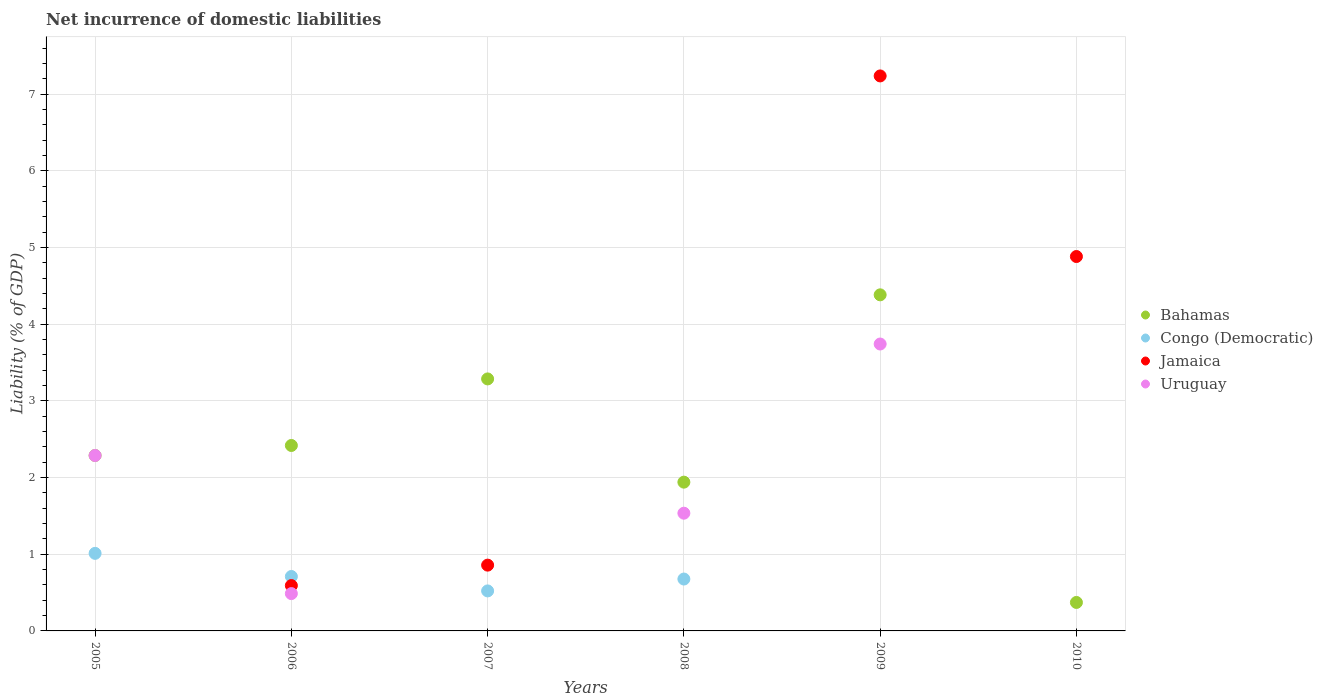How many different coloured dotlines are there?
Ensure brevity in your answer.  4. What is the net incurrence of domestic liabilities in Bahamas in 2005?
Offer a terse response. 2.29. Across all years, what is the maximum net incurrence of domestic liabilities in Congo (Democratic)?
Your answer should be very brief. 1.01. Across all years, what is the minimum net incurrence of domestic liabilities in Uruguay?
Your response must be concise. 0. What is the total net incurrence of domestic liabilities in Bahamas in the graph?
Give a very brief answer. 14.69. What is the difference between the net incurrence of domestic liabilities in Bahamas in 2008 and that in 2010?
Your answer should be compact. 1.57. What is the difference between the net incurrence of domestic liabilities in Bahamas in 2006 and the net incurrence of domestic liabilities in Jamaica in 2008?
Give a very brief answer. 2.42. What is the average net incurrence of domestic liabilities in Jamaica per year?
Offer a very short reply. 2.26. In the year 2006, what is the difference between the net incurrence of domestic liabilities in Uruguay and net incurrence of domestic liabilities in Congo (Democratic)?
Provide a succinct answer. -0.22. In how many years, is the net incurrence of domestic liabilities in Jamaica greater than 0.8 %?
Your response must be concise. 3. What is the ratio of the net incurrence of domestic liabilities in Congo (Democratic) in 2005 to that in 2007?
Ensure brevity in your answer.  1.94. Is the net incurrence of domestic liabilities in Bahamas in 2007 less than that in 2009?
Make the answer very short. Yes. What is the difference between the highest and the second highest net incurrence of domestic liabilities in Congo (Democratic)?
Provide a short and direct response. 0.3. What is the difference between the highest and the lowest net incurrence of domestic liabilities in Congo (Democratic)?
Provide a succinct answer. 1.01. Is it the case that in every year, the sum of the net incurrence of domestic liabilities in Jamaica and net incurrence of domestic liabilities in Congo (Democratic)  is greater than the sum of net incurrence of domestic liabilities in Bahamas and net incurrence of domestic liabilities in Uruguay?
Offer a very short reply. No. Is the net incurrence of domestic liabilities in Jamaica strictly greater than the net incurrence of domestic liabilities in Bahamas over the years?
Your response must be concise. No. Is the net incurrence of domestic liabilities in Jamaica strictly less than the net incurrence of domestic liabilities in Congo (Democratic) over the years?
Your response must be concise. No. How many dotlines are there?
Provide a succinct answer. 4. What is the difference between two consecutive major ticks on the Y-axis?
Make the answer very short. 1. Where does the legend appear in the graph?
Offer a terse response. Center right. How many legend labels are there?
Your answer should be very brief. 4. How are the legend labels stacked?
Offer a terse response. Vertical. What is the title of the graph?
Your response must be concise. Net incurrence of domestic liabilities. Does "Equatorial Guinea" appear as one of the legend labels in the graph?
Your response must be concise. No. What is the label or title of the X-axis?
Offer a terse response. Years. What is the label or title of the Y-axis?
Ensure brevity in your answer.  Liability (% of GDP). What is the Liability (% of GDP) of Bahamas in 2005?
Your answer should be compact. 2.29. What is the Liability (% of GDP) in Congo (Democratic) in 2005?
Give a very brief answer. 1.01. What is the Liability (% of GDP) of Jamaica in 2005?
Your response must be concise. 0. What is the Liability (% of GDP) in Uruguay in 2005?
Your response must be concise. 2.29. What is the Liability (% of GDP) of Bahamas in 2006?
Your response must be concise. 2.42. What is the Liability (% of GDP) of Congo (Democratic) in 2006?
Provide a short and direct response. 0.71. What is the Liability (% of GDP) of Jamaica in 2006?
Your response must be concise. 0.59. What is the Liability (% of GDP) in Uruguay in 2006?
Provide a succinct answer. 0.49. What is the Liability (% of GDP) in Bahamas in 2007?
Provide a succinct answer. 3.29. What is the Liability (% of GDP) of Congo (Democratic) in 2007?
Keep it short and to the point. 0.52. What is the Liability (% of GDP) in Jamaica in 2007?
Provide a short and direct response. 0.86. What is the Liability (% of GDP) of Uruguay in 2007?
Keep it short and to the point. 0. What is the Liability (% of GDP) in Bahamas in 2008?
Your answer should be very brief. 1.94. What is the Liability (% of GDP) in Congo (Democratic) in 2008?
Keep it short and to the point. 0.68. What is the Liability (% of GDP) of Jamaica in 2008?
Make the answer very short. 0. What is the Liability (% of GDP) in Uruguay in 2008?
Make the answer very short. 1.54. What is the Liability (% of GDP) of Bahamas in 2009?
Ensure brevity in your answer.  4.38. What is the Liability (% of GDP) in Jamaica in 2009?
Your answer should be very brief. 7.24. What is the Liability (% of GDP) in Uruguay in 2009?
Make the answer very short. 3.74. What is the Liability (% of GDP) in Bahamas in 2010?
Offer a very short reply. 0.37. What is the Liability (% of GDP) in Jamaica in 2010?
Make the answer very short. 4.88. What is the Liability (% of GDP) of Uruguay in 2010?
Offer a very short reply. 0. Across all years, what is the maximum Liability (% of GDP) of Bahamas?
Your answer should be very brief. 4.38. Across all years, what is the maximum Liability (% of GDP) of Congo (Democratic)?
Ensure brevity in your answer.  1.01. Across all years, what is the maximum Liability (% of GDP) of Jamaica?
Keep it short and to the point. 7.24. Across all years, what is the maximum Liability (% of GDP) of Uruguay?
Provide a succinct answer. 3.74. Across all years, what is the minimum Liability (% of GDP) of Bahamas?
Make the answer very short. 0.37. Across all years, what is the minimum Liability (% of GDP) in Congo (Democratic)?
Keep it short and to the point. 0. Across all years, what is the minimum Liability (% of GDP) in Jamaica?
Offer a very short reply. 0. What is the total Liability (% of GDP) of Bahamas in the graph?
Ensure brevity in your answer.  14.69. What is the total Liability (% of GDP) of Congo (Democratic) in the graph?
Ensure brevity in your answer.  2.92. What is the total Liability (% of GDP) of Jamaica in the graph?
Offer a terse response. 13.57. What is the total Liability (% of GDP) in Uruguay in the graph?
Your response must be concise. 8.05. What is the difference between the Liability (% of GDP) in Bahamas in 2005 and that in 2006?
Provide a succinct answer. -0.13. What is the difference between the Liability (% of GDP) of Congo (Democratic) in 2005 and that in 2006?
Your response must be concise. 0.3. What is the difference between the Liability (% of GDP) in Uruguay in 2005 and that in 2006?
Make the answer very short. 1.8. What is the difference between the Liability (% of GDP) in Bahamas in 2005 and that in 2007?
Your answer should be compact. -1. What is the difference between the Liability (% of GDP) of Congo (Democratic) in 2005 and that in 2007?
Your answer should be very brief. 0.49. What is the difference between the Liability (% of GDP) of Bahamas in 2005 and that in 2008?
Your answer should be very brief. 0.35. What is the difference between the Liability (% of GDP) in Congo (Democratic) in 2005 and that in 2008?
Give a very brief answer. 0.33. What is the difference between the Liability (% of GDP) in Uruguay in 2005 and that in 2008?
Your answer should be very brief. 0.75. What is the difference between the Liability (% of GDP) of Bahamas in 2005 and that in 2009?
Your answer should be compact. -2.1. What is the difference between the Liability (% of GDP) of Uruguay in 2005 and that in 2009?
Offer a very short reply. -1.45. What is the difference between the Liability (% of GDP) in Bahamas in 2005 and that in 2010?
Keep it short and to the point. 1.92. What is the difference between the Liability (% of GDP) in Bahamas in 2006 and that in 2007?
Offer a very short reply. -0.87. What is the difference between the Liability (% of GDP) of Congo (Democratic) in 2006 and that in 2007?
Offer a very short reply. 0.19. What is the difference between the Liability (% of GDP) in Jamaica in 2006 and that in 2007?
Your answer should be compact. -0.27. What is the difference between the Liability (% of GDP) of Bahamas in 2006 and that in 2008?
Provide a succinct answer. 0.48. What is the difference between the Liability (% of GDP) in Congo (Democratic) in 2006 and that in 2008?
Offer a very short reply. 0.03. What is the difference between the Liability (% of GDP) in Uruguay in 2006 and that in 2008?
Offer a terse response. -1.05. What is the difference between the Liability (% of GDP) in Bahamas in 2006 and that in 2009?
Offer a terse response. -1.96. What is the difference between the Liability (% of GDP) of Jamaica in 2006 and that in 2009?
Keep it short and to the point. -6.65. What is the difference between the Liability (% of GDP) of Uruguay in 2006 and that in 2009?
Offer a terse response. -3.25. What is the difference between the Liability (% of GDP) in Bahamas in 2006 and that in 2010?
Your response must be concise. 2.05. What is the difference between the Liability (% of GDP) in Jamaica in 2006 and that in 2010?
Provide a short and direct response. -4.29. What is the difference between the Liability (% of GDP) in Bahamas in 2007 and that in 2008?
Your answer should be compact. 1.35. What is the difference between the Liability (% of GDP) in Congo (Democratic) in 2007 and that in 2008?
Offer a terse response. -0.15. What is the difference between the Liability (% of GDP) in Bahamas in 2007 and that in 2009?
Ensure brevity in your answer.  -1.1. What is the difference between the Liability (% of GDP) of Jamaica in 2007 and that in 2009?
Provide a succinct answer. -6.38. What is the difference between the Liability (% of GDP) in Bahamas in 2007 and that in 2010?
Make the answer very short. 2.92. What is the difference between the Liability (% of GDP) in Jamaica in 2007 and that in 2010?
Provide a short and direct response. -4.02. What is the difference between the Liability (% of GDP) in Bahamas in 2008 and that in 2009?
Make the answer very short. -2.44. What is the difference between the Liability (% of GDP) in Uruguay in 2008 and that in 2009?
Ensure brevity in your answer.  -2.21. What is the difference between the Liability (% of GDP) of Bahamas in 2008 and that in 2010?
Ensure brevity in your answer.  1.57. What is the difference between the Liability (% of GDP) in Bahamas in 2009 and that in 2010?
Offer a terse response. 4.01. What is the difference between the Liability (% of GDP) of Jamaica in 2009 and that in 2010?
Offer a terse response. 2.36. What is the difference between the Liability (% of GDP) of Bahamas in 2005 and the Liability (% of GDP) of Congo (Democratic) in 2006?
Provide a short and direct response. 1.58. What is the difference between the Liability (% of GDP) in Bahamas in 2005 and the Liability (% of GDP) in Jamaica in 2006?
Your response must be concise. 1.7. What is the difference between the Liability (% of GDP) of Bahamas in 2005 and the Liability (% of GDP) of Uruguay in 2006?
Your response must be concise. 1.8. What is the difference between the Liability (% of GDP) in Congo (Democratic) in 2005 and the Liability (% of GDP) in Jamaica in 2006?
Your answer should be compact. 0.42. What is the difference between the Liability (% of GDP) in Congo (Democratic) in 2005 and the Liability (% of GDP) in Uruguay in 2006?
Ensure brevity in your answer.  0.52. What is the difference between the Liability (% of GDP) of Bahamas in 2005 and the Liability (% of GDP) of Congo (Democratic) in 2007?
Your answer should be very brief. 1.77. What is the difference between the Liability (% of GDP) of Bahamas in 2005 and the Liability (% of GDP) of Jamaica in 2007?
Your response must be concise. 1.43. What is the difference between the Liability (% of GDP) in Congo (Democratic) in 2005 and the Liability (% of GDP) in Jamaica in 2007?
Ensure brevity in your answer.  0.15. What is the difference between the Liability (% of GDP) of Bahamas in 2005 and the Liability (% of GDP) of Congo (Democratic) in 2008?
Ensure brevity in your answer.  1.61. What is the difference between the Liability (% of GDP) of Bahamas in 2005 and the Liability (% of GDP) of Uruguay in 2008?
Your answer should be compact. 0.75. What is the difference between the Liability (% of GDP) of Congo (Democratic) in 2005 and the Liability (% of GDP) of Uruguay in 2008?
Provide a short and direct response. -0.52. What is the difference between the Liability (% of GDP) of Bahamas in 2005 and the Liability (% of GDP) of Jamaica in 2009?
Your answer should be compact. -4.95. What is the difference between the Liability (% of GDP) of Bahamas in 2005 and the Liability (% of GDP) of Uruguay in 2009?
Your response must be concise. -1.45. What is the difference between the Liability (% of GDP) of Congo (Democratic) in 2005 and the Liability (% of GDP) of Jamaica in 2009?
Offer a very short reply. -6.23. What is the difference between the Liability (% of GDP) of Congo (Democratic) in 2005 and the Liability (% of GDP) of Uruguay in 2009?
Keep it short and to the point. -2.73. What is the difference between the Liability (% of GDP) in Bahamas in 2005 and the Liability (% of GDP) in Jamaica in 2010?
Give a very brief answer. -2.59. What is the difference between the Liability (% of GDP) of Congo (Democratic) in 2005 and the Liability (% of GDP) of Jamaica in 2010?
Offer a terse response. -3.87. What is the difference between the Liability (% of GDP) of Bahamas in 2006 and the Liability (% of GDP) of Congo (Democratic) in 2007?
Offer a very short reply. 1.9. What is the difference between the Liability (% of GDP) of Bahamas in 2006 and the Liability (% of GDP) of Jamaica in 2007?
Your answer should be very brief. 1.56. What is the difference between the Liability (% of GDP) in Congo (Democratic) in 2006 and the Liability (% of GDP) in Jamaica in 2007?
Give a very brief answer. -0.15. What is the difference between the Liability (% of GDP) of Bahamas in 2006 and the Liability (% of GDP) of Congo (Democratic) in 2008?
Keep it short and to the point. 1.74. What is the difference between the Liability (% of GDP) in Bahamas in 2006 and the Liability (% of GDP) in Uruguay in 2008?
Give a very brief answer. 0.88. What is the difference between the Liability (% of GDP) in Congo (Democratic) in 2006 and the Liability (% of GDP) in Uruguay in 2008?
Offer a very short reply. -0.83. What is the difference between the Liability (% of GDP) of Jamaica in 2006 and the Liability (% of GDP) of Uruguay in 2008?
Make the answer very short. -0.94. What is the difference between the Liability (% of GDP) in Bahamas in 2006 and the Liability (% of GDP) in Jamaica in 2009?
Provide a short and direct response. -4.82. What is the difference between the Liability (% of GDP) in Bahamas in 2006 and the Liability (% of GDP) in Uruguay in 2009?
Ensure brevity in your answer.  -1.32. What is the difference between the Liability (% of GDP) of Congo (Democratic) in 2006 and the Liability (% of GDP) of Jamaica in 2009?
Your response must be concise. -6.53. What is the difference between the Liability (% of GDP) of Congo (Democratic) in 2006 and the Liability (% of GDP) of Uruguay in 2009?
Make the answer very short. -3.03. What is the difference between the Liability (% of GDP) in Jamaica in 2006 and the Liability (% of GDP) in Uruguay in 2009?
Offer a very short reply. -3.15. What is the difference between the Liability (% of GDP) in Bahamas in 2006 and the Liability (% of GDP) in Jamaica in 2010?
Give a very brief answer. -2.46. What is the difference between the Liability (% of GDP) in Congo (Democratic) in 2006 and the Liability (% of GDP) in Jamaica in 2010?
Provide a succinct answer. -4.17. What is the difference between the Liability (% of GDP) of Bahamas in 2007 and the Liability (% of GDP) of Congo (Democratic) in 2008?
Your response must be concise. 2.61. What is the difference between the Liability (% of GDP) in Bahamas in 2007 and the Liability (% of GDP) in Uruguay in 2008?
Provide a short and direct response. 1.75. What is the difference between the Liability (% of GDP) of Congo (Democratic) in 2007 and the Liability (% of GDP) of Uruguay in 2008?
Offer a very short reply. -1.01. What is the difference between the Liability (% of GDP) in Jamaica in 2007 and the Liability (% of GDP) in Uruguay in 2008?
Provide a short and direct response. -0.68. What is the difference between the Liability (% of GDP) in Bahamas in 2007 and the Liability (% of GDP) in Jamaica in 2009?
Your response must be concise. -3.95. What is the difference between the Liability (% of GDP) in Bahamas in 2007 and the Liability (% of GDP) in Uruguay in 2009?
Your response must be concise. -0.46. What is the difference between the Liability (% of GDP) in Congo (Democratic) in 2007 and the Liability (% of GDP) in Jamaica in 2009?
Keep it short and to the point. -6.72. What is the difference between the Liability (% of GDP) in Congo (Democratic) in 2007 and the Liability (% of GDP) in Uruguay in 2009?
Provide a short and direct response. -3.22. What is the difference between the Liability (% of GDP) of Jamaica in 2007 and the Liability (% of GDP) of Uruguay in 2009?
Ensure brevity in your answer.  -2.88. What is the difference between the Liability (% of GDP) of Bahamas in 2007 and the Liability (% of GDP) of Jamaica in 2010?
Make the answer very short. -1.6. What is the difference between the Liability (% of GDP) in Congo (Democratic) in 2007 and the Liability (% of GDP) in Jamaica in 2010?
Your answer should be very brief. -4.36. What is the difference between the Liability (% of GDP) of Bahamas in 2008 and the Liability (% of GDP) of Jamaica in 2009?
Your answer should be very brief. -5.3. What is the difference between the Liability (% of GDP) of Bahamas in 2008 and the Liability (% of GDP) of Uruguay in 2009?
Ensure brevity in your answer.  -1.8. What is the difference between the Liability (% of GDP) of Congo (Democratic) in 2008 and the Liability (% of GDP) of Jamaica in 2009?
Offer a very short reply. -6.56. What is the difference between the Liability (% of GDP) in Congo (Democratic) in 2008 and the Liability (% of GDP) in Uruguay in 2009?
Your answer should be compact. -3.07. What is the difference between the Liability (% of GDP) in Bahamas in 2008 and the Liability (% of GDP) in Jamaica in 2010?
Offer a very short reply. -2.94. What is the difference between the Liability (% of GDP) in Congo (Democratic) in 2008 and the Liability (% of GDP) in Jamaica in 2010?
Your answer should be very brief. -4.21. What is the difference between the Liability (% of GDP) of Bahamas in 2009 and the Liability (% of GDP) of Jamaica in 2010?
Provide a short and direct response. -0.5. What is the average Liability (% of GDP) in Bahamas per year?
Ensure brevity in your answer.  2.45. What is the average Liability (% of GDP) of Congo (Democratic) per year?
Offer a very short reply. 0.49. What is the average Liability (% of GDP) in Jamaica per year?
Your answer should be compact. 2.26. What is the average Liability (% of GDP) of Uruguay per year?
Your answer should be compact. 1.34. In the year 2005, what is the difference between the Liability (% of GDP) of Bahamas and Liability (% of GDP) of Congo (Democratic)?
Ensure brevity in your answer.  1.28. In the year 2005, what is the difference between the Liability (% of GDP) in Congo (Democratic) and Liability (% of GDP) in Uruguay?
Your response must be concise. -1.28. In the year 2006, what is the difference between the Liability (% of GDP) in Bahamas and Liability (% of GDP) in Congo (Democratic)?
Your answer should be compact. 1.71. In the year 2006, what is the difference between the Liability (% of GDP) of Bahamas and Liability (% of GDP) of Jamaica?
Make the answer very short. 1.83. In the year 2006, what is the difference between the Liability (% of GDP) of Bahamas and Liability (% of GDP) of Uruguay?
Your answer should be compact. 1.93. In the year 2006, what is the difference between the Liability (% of GDP) of Congo (Democratic) and Liability (% of GDP) of Jamaica?
Your response must be concise. 0.12. In the year 2006, what is the difference between the Liability (% of GDP) in Congo (Democratic) and Liability (% of GDP) in Uruguay?
Your answer should be compact. 0.22. In the year 2006, what is the difference between the Liability (% of GDP) of Jamaica and Liability (% of GDP) of Uruguay?
Make the answer very short. 0.1. In the year 2007, what is the difference between the Liability (% of GDP) in Bahamas and Liability (% of GDP) in Congo (Democratic)?
Your response must be concise. 2.76. In the year 2007, what is the difference between the Liability (% of GDP) in Bahamas and Liability (% of GDP) in Jamaica?
Offer a very short reply. 2.43. In the year 2007, what is the difference between the Liability (% of GDP) of Congo (Democratic) and Liability (% of GDP) of Jamaica?
Make the answer very short. -0.34. In the year 2008, what is the difference between the Liability (% of GDP) of Bahamas and Liability (% of GDP) of Congo (Democratic)?
Offer a very short reply. 1.26. In the year 2008, what is the difference between the Liability (% of GDP) in Bahamas and Liability (% of GDP) in Uruguay?
Your answer should be very brief. 0.4. In the year 2008, what is the difference between the Liability (% of GDP) in Congo (Democratic) and Liability (% of GDP) in Uruguay?
Your answer should be compact. -0.86. In the year 2009, what is the difference between the Liability (% of GDP) in Bahamas and Liability (% of GDP) in Jamaica?
Provide a short and direct response. -2.85. In the year 2009, what is the difference between the Liability (% of GDP) in Bahamas and Liability (% of GDP) in Uruguay?
Give a very brief answer. 0.64. In the year 2009, what is the difference between the Liability (% of GDP) in Jamaica and Liability (% of GDP) in Uruguay?
Offer a very short reply. 3.5. In the year 2010, what is the difference between the Liability (% of GDP) in Bahamas and Liability (% of GDP) in Jamaica?
Provide a succinct answer. -4.51. What is the ratio of the Liability (% of GDP) in Bahamas in 2005 to that in 2006?
Provide a succinct answer. 0.95. What is the ratio of the Liability (% of GDP) in Congo (Democratic) in 2005 to that in 2006?
Keep it short and to the point. 1.43. What is the ratio of the Liability (% of GDP) of Uruguay in 2005 to that in 2006?
Your answer should be very brief. 4.7. What is the ratio of the Liability (% of GDP) in Bahamas in 2005 to that in 2007?
Give a very brief answer. 0.7. What is the ratio of the Liability (% of GDP) in Congo (Democratic) in 2005 to that in 2007?
Your answer should be very brief. 1.94. What is the ratio of the Liability (% of GDP) in Bahamas in 2005 to that in 2008?
Make the answer very short. 1.18. What is the ratio of the Liability (% of GDP) of Congo (Democratic) in 2005 to that in 2008?
Your response must be concise. 1.49. What is the ratio of the Liability (% of GDP) in Uruguay in 2005 to that in 2008?
Give a very brief answer. 1.49. What is the ratio of the Liability (% of GDP) in Bahamas in 2005 to that in 2009?
Your answer should be very brief. 0.52. What is the ratio of the Liability (% of GDP) of Uruguay in 2005 to that in 2009?
Offer a very short reply. 0.61. What is the ratio of the Liability (% of GDP) of Bahamas in 2005 to that in 2010?
Keep it short and to the point. 6.16. What is the ratio of the Liability (% of GDP) in Bahamas in 2006 to that in 2007?
Your answer should be compact. 0.74. What is the ratio of the Liability (% of GDP) in Congo (Democratic) in 2006 to that in 2007?
Keep it short and to the point. 1.36. What is the ratio of the Liability (% of GDP) in Jamaica in 2006 to that in 2007?
Give a very brief answer. 0.69. What is the ratio of the Liability (% of GDP) in Bahamas in 2006 to that in 2008?
Give a very brief answer. 1.25. What is the ratio of the Liability (% of GDP) in Congo (Democratic) in 2006 to that in 2008?
Ensure brevity in your answer.  1.05. What is the ratio of the Liability (% of GDP) in Uruguay in 2006 to that in 2008?
Ensure brevity in your answer.  0.32. What is the ratio of the Liability (% of GDP) of Bahamas in 2006 to that in 2009?
Make the answer very short. 0.55. What is the ratio of the Liability (% of GDP) of Jamaica in 2006 to that in 2009?
Offer a very short reply. 0.08. What is the ratio of the Liability (% of GDP) in Uruguay in 2006 to that in 2009?
Offer a very short reply. 0.13. What is the ratio of the Liability (% of GDP) in Bahamas in 2006 to that in 2010?
Give a very brief answer. 6.51. What is the ratio of the Liability (% of GDP) in Jamaica in 2006 to that in 2010?
Keep it short and to the point. 0.12. What is the ratio of the Liability (% of GDP) of Bahamas in 2007 to that in 2008?
Offer a terse response. 1.69. What is the ratio of the Liability (% of GDP) in Congo (Democratic) in 2007 to that in 2008?
Give a very brief answer. 0.77. What is the ratio of the Liability (% of GDP) in Bahamas in 2007 to that in 2009?
Ensure brevity in your answer.  0.75. What is the ratio of the Liability (% of GDP) in Jamaica in 2007 to that in 2009?
Keep it short and to the point. 0.12. What is the ratio of the Liability (% of GDP) of Bahamas in 2007 to that in 2010?
Give a very brief answer. 8.85. What is the ratio of the Liability (% of GDP) of Jamaica in 2007 to that in 2010?
Your answer should be compact. 0.18. What is the ratio of the Liability (% of GDP) of Bahamas in 2008 to that in 2009?
Offer a very short reply. 0.44. What is the ratio of the Liability (% of GDP) of Uruguay in 2008 to that in 2009?
Your answer should be compact. 0.41. What is the ratio of the Liability (% of GDP) of Bahamas in 2008 to that in 2010?
Your answer should be compact. 5.23. What is the ratio of the Liability (% of GDP) of Bahamas in 2009 to that in 2010?
Offer a terse response. 11.8. What is the ratio of the Liability (% of GDP) in Jamaica in 2009 to that in 2010?
Your answer should be compact. 1.48. What is the difference between the highest and the second highest Liability (% of GDP) of Bahamas?
Your answer should be compact. 1.1. What is the difference between the highest and the second highest Liability (% of GDP) of Congo (Democratic)?
Offer a terse response. 0.3. What is the difference between the highest and the second highest Liability (% of GDP) of Jamaica?
Your answer should be compact. 2.36. What is the difference between the highest and the second highest Liability (% of GDP) in Uruguay?
Provide a short and direct response. 1.45. What is the difference between the highest and the lowest Liability (% of GDP) in Bahamas?
Offer a terse response. 4.01. What is the difference between the highest and the lowest Liability (% of GDP) in Congo (Democratic)?
Provide a short and direct response. 1.01. What is the difference between the highest and the lowest Liability (% of GDP) of Jamaica?
Provide a succinct answer. 7.24. What is the difference between the highest and the lowest Liability (% of GDP) in Uruguay?
Provide a short and direct response. 3.74. 